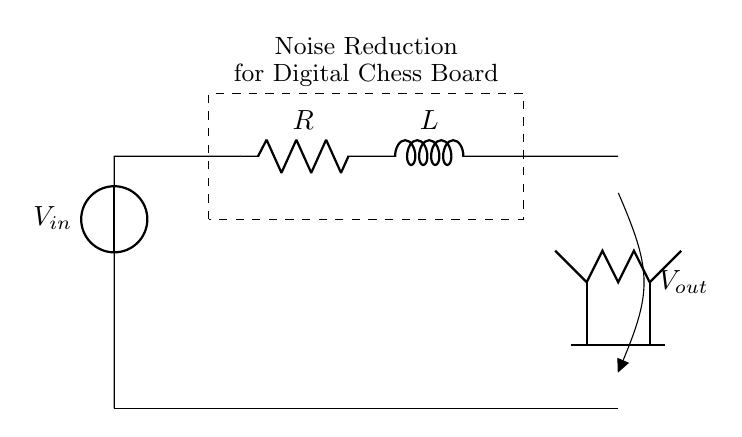What components are present in this circuit? The circuit diagram shows a resistor and an inductor. These are the primary components used for noise reduction in the signal.
Answer: Resistor and Inductor What is the function of the resistor in this circuit? The resistor limits the current flowing through the inductor, helping to control the rate of charge and discharge in the circuit, thus contributing to noise filtering.
Answer: Current Limiting What is the voltage source labeled as? The voltage source in the circuit is labeled as V-in, which indicates that it provides the input voltage to the circuit.
Answer: V-in What does V-out represent in this circuit? V-out represents the output voltage of the circuit, which is the voltage measured across the output terminals after noise reduction has taken place.
Answer: V-out What does the dashed rectangle signify in the diagram? The dashed rectangle signifies the area designated for noise reduction, indicating the section of the circuit dedicated to attenuating noise signals before they reach the output.
Answer: Noise Reduction Area What is the overall purpose of this RL filter circuit in a digital chessboard? The overall purpose is to filter out noise from the signal to ensure accurate and reliable performance of the digital chess board by providing a cleaner output signal.
Answer: Noise Reduction How does an inductor contribute to noise reduction in this circuit? The inductor stores energy in a magnetic field when current flows through it, which helps to smooth out fluctuations in the current and voltage, thus reducing high-frequency noise.
Answer: Energy Storage 